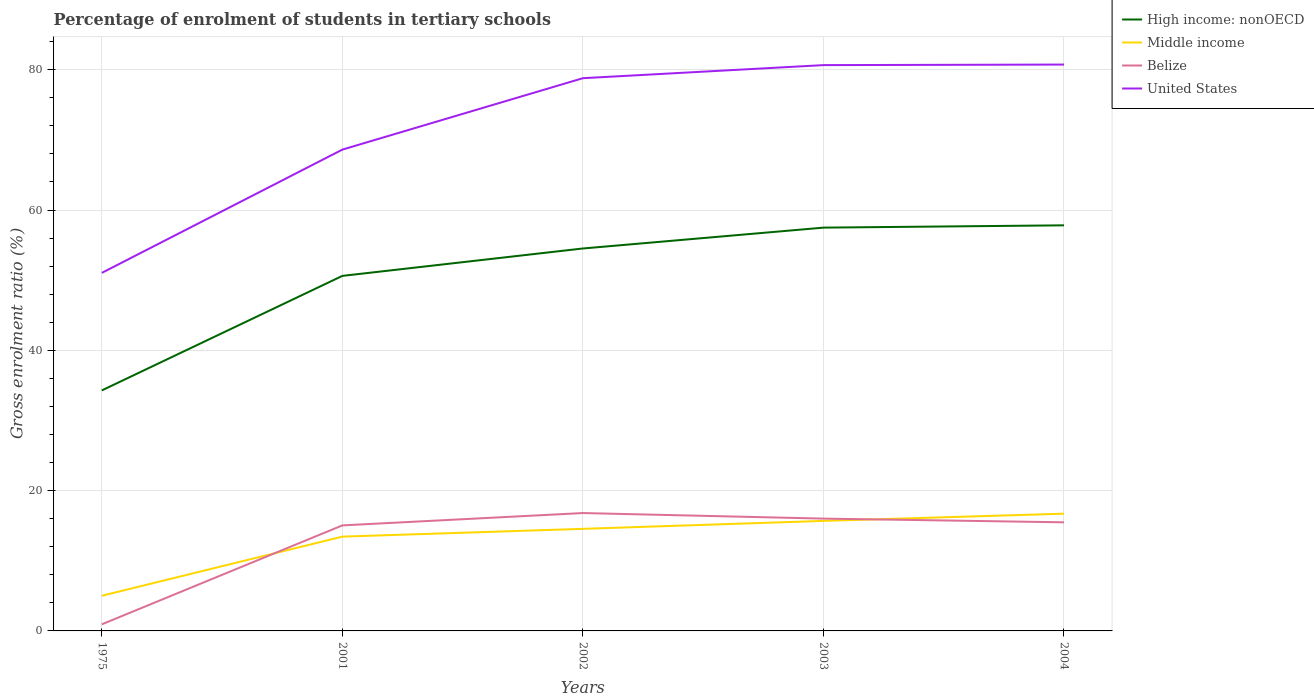Does the line corresponding to Middle income intersect with the line corresponding to High income: nonOECD?
Offer a very short reply. No. Across all years, what is the maximum percentage of students enrolled in tertiary schools in High income: nonOECD?
Give a very brief answer. 34.29. In which year was the percentage of students enrolled in tertiary schools in United States maximum?
Your answer should be very brief. 1975. What is the total percentage of students enrolled in tertiary schools in High income: nonOECD in the graph?
Provide a succinct answer. -23.53. What is the difference between the highest and the second highest percentage of students enrolled in tertiary schools in Belize?
Give a very brief answer. 15.86. How many lines are there?
Provide a succinct answer. 4. What is the difference between two consecutive major ticks on the Y-axis?
Provide a short and direct response. 20. Does the graph contain any zero values?
Provide a short and direct response. No. Does the graph contain grids?
Your response must be concise. Yes. How many legend labels are there?
Your answer should be compact. 4. How are the legend labels stacked?
Your answer should be compact. Vertical. What is the title of the graph?
Give a very brief answer. Percentage of enrolment of students in tertiary schools. Does "Bolivia" appear as one of the legend labels in the graph?
Provide a short and direct response. No. What is the label or title of the Y-axis?
Keep it short and to the point. Gross enrolment ratio (%). What is the Gross enrolment ratio (%) in High income: nonOECD in 1975?
Provide a succinct answer. 34.29. What is the Gross enrolment ratio (%) of Middle income in 1975?
Ensure brevity in your answer.  5.01. What is the Gross enrolment ratio (%) in Belize in 1975?
Offer a very short reply. 0.94. What is the Gross enrolment ratio (%) of United States in 1975?
Offer a very short reply. 51.04. What is the Gross enrolment ratio (%) in High income: nonOECD in 2001?
Offer a terse response. 50.62. What is the Gross enrolment ratio (%) of Middle income in 2001?
Your answer should be compact. 13.44. What is the Gross enrolment ratio (%) in Belize in 2001?
Give a very brief answer. 15.04. What is the Gross enrolment ratio (%) in United States in 2001?
Provide a succinct answer. 68.62. What is the Gross enrolment ratio (%) in High income: nonOECD in 2002?
Your answer should be very brief. 54.52. What is the Gross enrolment ratio (%) in Middle income in 2002?
Keep it short and to the point. 14.55. What is the Gross enrolment ratio (%) of Belize in 2002?
Ensure brevity in your answer.  16.8. What is the Gross enrolment ratio (%) of United States in 2002?
Your response must be concise. 78.8. What is the Gross enrolment ratio (%) in High income: nonOECD in 2003?
Give a very brief answer. 57.49. What is the Gross enrolment ratio (%) of Middle income in 2003?
Provide a succinct answer. 15.69. What is the Gross enrolment ratio (%) of Belize in 2003?
Keep it short and to the point. 16.01. What is the Gross enrolment ratio (%) of United States in 2003?
Offer a very short reply. 80.66. What is the Gross enrolment ratio (%) in High income: nonOECD in 2004?
Provide a short and direct response. 57.82. What is the Gross enrolment ratio (%) in Middle income in 2004?
Provide a succinct answer. 16.71. What is the Gross enrolment ratio (%) in Belize in 2004?
Provide a succinct answer. 15.48. What is the Gross enrolment ratio (%) in United States in 2004?
Offer a terse response. 80.74. Across all years, what is the maximum Gross enrolment ratio (%) of High income: nonOECD?
Your answer should be compact. 57.82. Across all years, what is the maximum Gross enrolment ratio (%) in Middle income?
Keep it short and to the point. 16.71. Across all years, what is the maximum Gross enrolment ratio (%) in Belize?
Provide a succinct answer. 16.8. Across all years, what is the maximum Gross enrolment ratio (%) in United States?
Provide a short and direct response. 80.74. Across all years, what is the minimum Gross enrolment ratio (%) of High income: nonOECD?
Ensure brevity in your answer.  34.29. Across all years, what is the minimum Gross enrolment ratio (%) of Middle income?
Give a very brief answer. 5.01. Across all years, what is the minimum Gross enrolment ratio (%) of Belize?
Provide a succinct answer. 0.94. Across all years, what is the minimum Gross enrolment ratio (%) in United States?
Offer a very short reply. 51.04. What is the total Gross enrolment ratio (%) in High income: nonOECD in the graph?
Ensure brevity in your answer.  254.74. What is the total Gross enrolment ratio (%) in Middle income in the graph?
Ensure brevity in your answer.  65.41. What is the total Gross enrolment ratio (%) of Belize in the graph?
Ensure brevity in your answer.  64.29. What is the total Gross enrolment ratio (%) in United States in the graph?
Keep it short and to the point. 359.87. What is the difference between the Gross enrolment ratio (%) in High income: nonOECD in 1975 and that in 2001?
Ensure brevity in your answer.  -16.33. What is the difference between the Gross enrolment ratio (%) of Middle income in 1975 and that in 2001?
Keep it short and to the point. -8.43. What is the difference between the Gross enrolment ratio (%) in Belize in 1975 and that in 2001?
Your answer should be compact. -14.1. What is the difference between the Gross enrolment ratio (%) of United States in 1975 and that in 2001?
Make the answer very short. -17.57. What is the difference between the Gross enrolment ratio (%) of High income: nonOECD in 1975 and that in 2002?
Keep it short and to the point. -20.23. What is the difference between the Gross enrolment ratio (%) in Middle income in 1975 and that in 2002?
Provide a short and direct response. -9.54. What is the difference between the Gross enrolment ratio (%) in Belize in 1975 and that in 2002?
Ensure brevity in your answer.  -15.86. What is the difference between the Gross enrolment ratio (%) of United States in 1975 and that in 2002?
Your answer should be compact. -27.76. What is the difference between the Gross enrolment ratio (%) in High income: nonOECD in 1975 and that in 2003?
Provide a short and direct response. -23.21. What is the difference between the Gross enrolment ratio (%) of Middle income in 1975 and that in 2003?
Keep it short and to the point. -10.67. What is the difference between the Gross enrolment ratio (%) of Belize in 1975 and that in 2003?
Provide a succinct answer. -15.07. What is the difference between the Gross enrolment ratio (%) in United States in 1975 and that in 2003?
Provide a short and direct response. -29.62. What is the difference between the Gross enrolment ratio (%) of High income: nonOECD in 1975 and that in 2004?
Your answer should be very brief. -23.53. What is the difference between the Gross enrolment ratio (%) in Middle income in 1975 and that in 2004?
Ensure brevity in your answer.  -11.7. What is the difference between the Gross enrolment ratio (%) of Belize in 1975 and that in 2004?
Your answer should be compact. -14.54. What is the difference between the Gross enrolment ratio (%) in United States in 1975 and that in 2004?
Ensure brevity in your answer.  -29.7. What is the difference between the Gross enrolment ratio (%) of High income: nonOECD in 2001 and that in 2002?
Make the answer very short. -3.91. What is the difference between the Gross enrolment ratio (%) of Middle income in 2001 and that in 2002?
Your answer should be very brief. -1.11. What is the difference between the Gross enrolment ratio (%) of Belize in 2001 and that in 2002?
Give a very brief answer. -1.76. What is the difference between the Gross enrolment ratio (%) in United States in 2001 and that in 2002?
Ensure brevity in your answer.  -10.18. What is the difference between the Gross enrolment ratio (%) in High income: nonOECD in 2001 and that in 2003?
Give a very brief answer. -6.88. What is the difference between the Gross enrolment ratio (%) of Middle income in 2001 and that in 2003?
Offer a very short reply. -2.24. What is the difference between the Gross enrolment ratio (%) of Belize in 2001 and that in 2003?
Provide a short and direct response. -0.97. What is the difference between the Gross enrolment ratio (%) of United States in 2001 and that in 2003?
Provide a succinct answer. -12.04. What is the difference between the Gross enrolment ratio (%) in High income: nonOECD in 2001 and that in 2004?
Ensure brevity in your answer.  -7.21. What is the difference between the Gross enrolment ratio (%) in Middle income in 2001 and that in 2004?
Your response must be concise. -3.27. What is the difference between the Gross enrolment ratio (%) of Belize in 2001 and that in 2004?
Give a very brief answer. -0.44. What is the difference between the Gross enrolment ratio (%) of United States in 2001 and that in 2004?
Keep it short and to the point. -12.12. What is the difference between the Gross enrolment ratio (%) in High income: nonOECD in 2002 and that in 2003?
Your answer should be compact. -2.97. What is the difference between the Gross enrolment ratio (%) of Middle income in 2002 and that in 2003?
Provide a short and direct response. -1.13. What is the difference between the Gross enrolment ratio (%) in Belize in 2002 and that in 2003?
Your answer should be compact. 0.79. What is the difference between the Gross enrolment ratio (%) in United States in 2002 and that in 2003?
Make the answer very short. -1.86. What is the difference between the Gross enrolment ratio (%) in High income: nonOECD in 2002 and that in 2004?
Ensure brevity in your answer.  -3.3. What is the difference between the Gross enrolment ratio (%) in Middle income in 2002 and that in 2004?
Ensure brevity in your answer.  -2.16. What is the difference between the Gross enrolment ratio (%) of Belize in 2002 and that in 2004?
Make the answer very short. 1.32. What is the difference between the Gross enrolment ratio (%) in United States in 2002 and that in 2004?
Offer a terse response. -1.94. What is the difference between the Gross enrolment ratio (%) of High income: nonOECD in 2003 and that in 2004?
Offer a terse response. -0.33. What is the difference between the Gross enrolment ratio (%) of Middle income in 2003 and that in 2004?
Your response must be concise. -1.03. What is the difference between the Gross enrolment ratio (%) of Belize in 2003 and that in 2004?
Give a very brief answer. 0.53. What is the difference between the Gross enrolment ratio (%) of United States in 2003 and that in 2004?
Provide a succinct answer. -0.08. What is the difference between the Gross enrolment ratio (%) in High income: nonOECD in 1975 and the Gross enrolment ratio (%) in Middle income in 2001?
Offer a terse response. 20.85. What is the difference between the Gross enrolment ratio (%) in High income: nonOECD in 1975 and the Gross enrolment ratio (%) in Belize in 2001?
Your response must be concise. 19.24. What is the difference between the Gross enrolment ratio (%) in High income: nonOECD in 1975 and the Gross enrolment ratio (%) in United States in 2001?
Your response must be concise. -34.33. What is the difference between the Gross enrolment ratio (%) in Middle income in 1975 and the Gross enrolment ratio (%) in Belize in 2001?
Offer a very short reply. -10.03. What is the difference between the Gross enrolment ratio (%) in Middle income in 1975 and the Gross enrolment ratio (%) in United States in 2001?
Provide a short and direct response. -63.6. What is the difference between the Gross enrolment ratio (%) of Belize in 1975 and the Gross enrolment ratio (%) of United States in 2001?
Your answer should be very brief. -67.68. What is the difference between the Gross enrolment ratio (%) of High income: nonOECD in 1975 and the Gross enrolment ratio (%) of Middle income in 2002?
Your answer should be very brief. 19.74. What is the difference between the Gross enrolment ratio (%) in High income: nonOECD in 1975 and the Gross enrolment ratio (%) in Belize in 2002?
Provide a succinct answer. 17.48. What is the difference between the Gross enrolment ratio (%) of High income: nonOECD in 1975 and the Gross enrolment ratio (%) of United States in 2002?
Offer a very short reply. -44.51. What is the difference between the Gross enrolment ratio (%) of Middle income in 1975 and the Gross enrolment ratio (%) of Belize in 2002?
Your answer should be very brief. -11.79. What is the difference between the Gross enrolment ratio (%) of Middle income in 1975 and the Gross enrolment ratio (%) of United States in 2002?
Ensure brevity in your answer.  -73.79. What is the difference between the Gross enrolment ratio (%) of Belize in 1975 and the Gross enrolment ratio (%) of United States in 2002?
Offer a very short reply. -77.86. What is the difference between the Gross enrolment ratio (%) in High income: nonOECD in 1975 and the Gross enrolment ratio (%) in Middle income in 2003?
Ensure brevity in your answer.  18.6. What is the difference between the Gross enrolment ratio (%) of High income: nonOECD in 1975 and the Gross enrolment ratio (%) of Belize in 2003?
Make the answer very short. 18.28. What is the difference between the Gross enrolment ratio (%) in High income: nonOECD in 1975 and the Gross enrolment ratio (%) in United States in 2003?
Offer a very short reply. -46.37. What is the difference between the Gross enrolment ratio (%) in Middle income in 1975 and the Gross enrolment ratio (%) in Belize in 2003?
Your answer should be compact. -11. What is the difference between the Gross enrolment ratio (%) in Middle income in 1975 and the Gross enrolment ratio (%) in United States in 2003?
Keep it short and to the point. -75.65. What is the difference between the Gross enrolment ratio (%) of Belize in 1975 and the Gross enrolment ratio (%) of United States in 2003?
Your answer should be compact. -79.72. What is the difference between the Gross enrolment ratio (%) of High income: nonOECD in 1975 and the Gross enrolment ratio (%) of Middle income in 2004?
Offer a very short reply. 17.58. What is the difference between the Gross enrolment ratio (%) in High income: nonOECD in 1975 and the Gross enrolment ratio (%) in Belize in 2004?
Ensure brevity in your answer.  18.81. What is the difference between the Gross enrolment ratio (%) in High income: nonOECD in 1975 and the Gross enrolment ratio (%) in United States in 2004?
Provide a short and direct response. -46.45. What is the difference between the Gross enrolment ratio (%) in Middle income in 1975 and the Gross enrolment ratio (%) in Belize in 2004?
Offer a terse response. -10.47. What is the difference between the Gross enrolment ratio (%) of Middle income in 1975 and the Gross enrolment ratio (%) of United States in 2004?
Give a very brief answer. -75.73. What is the difference between the Gross enrolment ratio (%) of Belize in 1975 and the Gross enrolment ratio (%) of United States in 2004?
Ensure brevity in your answer.  -79.8. What is the difference between the Gross enrolment ratio (%) of High income: nonOECD in 2001 and the Gross enrolment ratio (%) of Middle income in 2002?
Offer a very short reply. 36.06. What is the difference between the Gross enrolment ratio (%) of High income: nonOECD in 2001 and the Gross enrolment ratio (%) of Belize in 2002?
Offer a terse response. 33.81. What is the difference between the Gross enrolment ratio (%) in High income: nonOECD in 2001 and the Gross enrolment ratio (%) in United States in 2002?
Give a very brief answer. -28.18. What is the difference between the Gross enrolment ratio (%) in Middle income in 2001 and the Gross enrolment ratio (%) in Belize in 2002?
Offer a very short reply. -3.36. What is the difference between the Gross enrolment ratio (%) in Middle income in 2001 and the Gross enrolment ratio (%) in United States in 2002?
Keep it short and to the point. -65.36. What is the difference between the Gross enrolment ratio (%) in Belize in 2001 and the Gross enrolment ratio (%) in United States in 2002?
Your answer should be compact. -63.75. What is the difference between the Gross enrolment ratio (%) in High income: nonOECD in 2001 and the Gross enrolment ratio (%) in Middle income in 2003?
Provide a short and direct response. 34.93. What is the difference between the Gross enrolment ratio (%) in High income: nonOECD in 2001 and the Gross enrolment ratio (%) in Belize in 2003?
Provide a succinct answer. 34.6. What is the difference between the Gross enrolment ratio (%) of High income: nonOECD in 2001 and the Gross enrolment ratio (%) of United States in 2003?
Your response must be concise. -30.05. What is the difference between the Gross enrolment ratio (%) of Middle income in 2001 and the Gross enrolment ratio (%) of Belize in 2003?
Your response must be concise. -2.57. What is the difference between the Gross enrolment ratio (%) in Middle income in 2001 and the Gross enrolment ratio (%) in United States in 2003?
Give a very brief answer. -67.22. What is the difference between the Gross enrolment ratio (%) in Belize in 2001 and the Gross enrolment ratio (%) in United States in 2003?
Make the answer very short. -65.62. What is the difference between the Gross enrolment ratio (%) of High income: nonOECD in 2001 and the Gross enrolment ratio (%) of Middle income in 2004?
Provide a short and direct response. 33.9. What is the difference between the Gross enrolment ratio (%) in High income: nonOECD in 2001 and the Gross enrolment ratio (%) in Belize in 2004?
Provide a short and direct response. 35.13. What is the difference between the Gross enrolment ratio (%) in High income: nonOECD in 2001 and the Gross enrolment ratio (%) in United States in 2004?
Your answer should be compact. -30.13. What is the difference between the Gross enrolment ratio (%) of Middle income in 2001 and the Gross enrolment ratio (%) of Belize in 2004?
Offer a terse response. -2.04. What is the difference between the Gross enrolment ratio (%) of Middle income in 2001 and the Gross enrolment ratio (%) of United States in 2004?
Keep it short and to the point. -67.3. What is the difference between the Gross enrolment ratio (%) in Belize in 2001 and the Gross enrolment ratio (%) in United States in 2004?
Your response must be concise. -65.7. What is the difference between the Gross enrolment ratio (%) of High income: nonOECD in 2002 and the Gross enrolment ratio (%) of Middle income in 2003?
Make the answer very short. 38.84. What is the difference between the Gross enrolment ratio (%) of High income: nonOECD in 2002 and the Gross enrolment ratio (%) of Belize in 2003?
Keep it short and to the point. 38.51. What is the difference between the Gross enrolment ratio (%) of High income: nonOECD in 2002 and the Gross enrolment ratio (%) of United States in 2003?
Your answer should be compact. -26.14. What is the difference between the Gross enrolment ratio (%) of Middle income in 2002 and the Gross enrolment ratio (%) of Belize in 2003?
Provide a short and direct response. -1.46. What is the difference between the Gross enrolment ratio (%) of Middle income in 2002 and the Gross enrolment ratio (%) of United States in 2003?
Keep it short and to the point. -66.11. What is the difference between the Gross enrolment ratio (%) in Belize in 2002 and the Gross enrolment ratio (%) in United States in 2003?
Provide a short and direct response. -63.86. What is the difference between the Gross enrolment ratio (%) in High income: nonOECD in 2002 and the Gross enrolment ratio (%) in Middle income in 2004?
Ensure brevity in your answer.  37.81. What is the difference between the Gross enrolment ratio (%) of High income: nonOECD in 2002 and the Gross enrolment ratio (%) of Belize in 2004?
Offer a terse response. 39.04. What is the difference between the Gross enrolment ratio (%) in High income: nonOECD in 2002 and the Gross enrolment ratio (%) in United States in 2004?
Your answer should be compact. -26.22. What is the difference between the Gross enrolment ratio (%) of Middle income in 2002 and the Gross enrolment ratio (%) of Belize in 2004?
Keep it short and to the point. -0.93. What is the difference between the Gross enrolment ratio (%) of Middle income in 2002 and the Gross enrolment ratio (%) of United States in 2004?
Your response must be concise. -66.19. What is the difference between the Gross enrolment ratio (%) in Belize in 2002 and the Gross enrolment ratio (%) in United States in 2004?
Keep it short and to the point. -63.94. What is the difference between the Gross enrolment ratio (%) in High income: nonOECD in 2003 and the Gross enrolment ratio (%) in Middle income in 2004?
Your answer should be very brief. 40.78. What is the difference between the Gross enrolment ratio (%) of High income: nonOECD in 2003 and the Gross enrolment ratio (%) of Belize in 2004?
Your response must be concise. 42.01. What is the difference between the Gross enrolment ratio (%) in High income: nonOECD in 2003 and the Gross enrolment ratio (%) in United States in 2004?
Your answer should be compact. -23.25. What is the difference between the Gross enrolment ratio (%) in Middle income in 2003 and the Gross enrolment ratio (%) in Belize in 2004?
Give a very brief answer. 0.2. What is the difference between the Gross enrolment ratio (%) of Middle income in 2003 and the Gross enrolment ratio (%) of United States in 2004?
Your answer should be very brief. -65.06. What is the difference between the Gross enrolment ratio (%) in Belize in 2003 and the Gross enrolment ratio (%) in United States in 2004?
Ensure brevity in your answer.  -64.73. What is the average Gross enrolment ratio (%) in High income: nonOECD per year?
Give a very brief answer. 50.95. What is the average Gross enrolment ratio (%) in Middle income per year?
Provide a short and direct response. 13.08. What is the average Gross enrolment ratio (%) of Belize per year?
Your response must be concise. 12.86. What is the average Gross enrolment ratio (%) in United States per year?
Provide a succinct answer. 71.97. In the year 1975, what is the difference between the Gross enrolment ratio (%) of High income: nonOECD and Gross enrolment ratio (%) of Middle income?
Offer a very short reply. 29.28. In the year 1975, what is the difference between the Gross enrolment ratio (%) of High income: nonOECD and Gross enrolment ratio (%) of Belize?
Provide a succinct answer. 33.35. In the year 1975, what is the difference between the Gross enrolment ratio (%) of High income: nonOECD and Gross enrolment ratio (%) of United States?
Make the answer very short. -16.76. In the year 1975, what is the difference between the Gross enrolment ratio (%) of Middle income and Gross enrolment ratio (%) of Belize?
Give a very brief answer. 4.07. In the year 1975, what is the difference between the Gross enrolment ratio (%) in Middle income and Gross enrolment ratio (%) in United States?
Your answer should be very brief. -46.03. In the year 1975, what is the difference between the Gross enrolment ratio (%) of Belize and Gross enrolment ratio (%) of United States?
Your response must be concise. -50.1. In the year 2001, what is the difference between the Gross enrolment ratio (%) in High income: nonOECD and Gross enrolment ratio (%) in Middle income?
Give a very brief answer. 37.17. In the year 2001, what is the difference between the Gross enrolment ratio (%) of High income: nonOECD and Gross enrolment ratio (%) of Belize?
Provide a succinct answer. 35.57. In the year 2001, what is the difference between the Gross enrolment ratio (%) in High income: nonOECD and Gross enrolment ratio (%) in United States?
Keep it short and to the point. -18. In the year 2001, what is the difference between the Gross enrolment ratio (%) of Middle income and Gross enrolment ratio (%) of Belize?
Make the answer very short. -1.6. In the year 2001, what is the difference between the Gross enrolment ratio (%) in Middle income and Gross enrolment ratio (%) in United States?
Your answer should be very brief. -55.18. In the year 2001, what is the difference between the Gross enrolment ratio (%) of Belize and Gross enrolment ratio (%) of United States?
Provide a succinct answer. -53.57. In the year 2002, what is the difference between the Gross enrolment ratio (%) of High income: nonOECD and Gross enrolment ratio (%) of Middle income?
Provide a succinct answer. 39.97. In the year 2002, what is the difference between the Gross enrolment ratio (%) in High income: nonOECD and Gross enrolment ratio (%) in Belize?
Offer a terse response. 37.72. In the year 2002, what is the difference between the Gross enrolment ratio (%) in High income: nonOECD and Gross enrolment ratio (%) in United States?
Your answer should be very brief. -24.28. In the year 2002, what is the difference between the Gross enrolment ratio (%) in Middle income and Gross enrolment ratio (%) in Belize?
Your response must be concise. -2.25. In the year 2002, what is the difference between the Gross enrolment ratio (%) in Middle income and Gross enrolment ratio (%) in United States?
Keep it short and to the point. -64.25. In the year 2002, what is the difference between the Gross enrolment ratio (%) of Belize and Gross enrolment ratio (%) of United States?
Provide a succinct answer. -62. In the year 2003, what is the difference between the Gross enrolment ratio (%) in High income: nonOECD and Gross enrolment ratio (%) in Middle income?
Your response must be concise. 41.81. In the year 2003, what is the difference between the Gross enrolment ratio (%) in High income: nonOECD and Gross enrolment ratio (%) in Belize?
Provide a short and direct response. 41.48. In the year 2003, what is the difference between the Gross enrolment ratio (%) in High income: nonOECD and Gross enrolment ratio (%) in United States?
Make the answer very short. -23.17. In the year 2003, what is the difference between the Gross enrolment ratio (%) of Middle income and Gross enrolment ratio (%) of Belize?
Keep it short and to the point. -0.33. In the year 2003, what is the difference between the Gross enrolment ratio (%) of Middle income and Gross enrolment ratio (%) of United States?
Your answer should be compact. -64.98. In the year 2003, what is the difference between the Gross enrolment ratio (%) of Belize and Gross enrolment ratio (%) of United States?
Give a very brief answer. -64.65. In the year 2004, what is the difference between the Gross enrolment ratio (%) in High income: nonOECD and Gross enrolment ratio (%) in Middle income?
Your answer should be very brief. 41.11. In the year 2004, what is the difference between the Gross enrolment ratio (%) in High income: nonOECD and Gross enrolment ratio (%) in Belize?
Your answer should be very brief. 42.34. In the year 2004, what is the difference between the Gross enrolment ratio (%) in High income: nonOECD and Gross enrolment ratio (%) in United States?
Offer a terse response. -22.92. In the year 2004, what is the difference between the Gross enrolment ratio (%) of Middle income and Gross enrolment ratio (%) of Belize?
Your answer should be very brief. 1.23. In the year 2004, what is the difference between the Gross enrolment ratio (%) of Middle income and Gross enrolment ratio (%) of United States?
Give a very brief answer. -64.03. In the year 2004, what is the difference between the Gross enrolment ratio (%) in Belize and Gross enrolment ratio (%) in United States?
Your response must be concise. -65.26. What is the ratio of the Gross enrolment ratio (%) in High income: nonOECD in 1975 to that in 2001?
Give a very brief answer. 0.68. What is the ratio of the Gross enrolment ratio (%) in Middle income in 1975 to that in 2001?
Offer a very short reply. 0.37. What is the ratio of the Gross enrolment ratio (%) in Belize in 1975 to that in 2001?
Provide a short and direct response. 0.06. What is the ratio of the Gross enrolment ratio (%) in United States in 1975 to that in 2001?
Keep it short and to the point. 0.74. What is the ratio of the Gross enrolment ratio (%) in High income: nonOECD in 1975 to that in 2002?
Provide a succinct answer. 0.63. What is the ratio of the Gross enrolment ratio (%) in Middle income in 1975 to that in 2002?
Give a very brief answer. 0.34. What is the ratio of the Gross enrolment ratio (%) in Belize in 1975 to that in 2002?
Provide a succinct answer. 0.06. What is the ratio of the Gross enrolment ratio (%) of United States in 1975 to that in 2002?
Your response must be concise. 0.65. What is the ratio of the Gross enrolment ratio (%) in High income: nonOECD in 1975 to that in 2003?
Your answer should be very brief. 0.6. What is the ratio of the Gross enrolment ratio (%) of Middle income in 1975 to that in 2003?
Your answer should be compact. 0.32. What is the ratio of the Gross enrolment ratio (%) in Belize in 1975 to that in 2003?
Offer a terse response. 0.06. What is the ratio of the Gross enrolment ratio (%) of United States in 1975 to that in 2003?
Offer a terse response. 0.63. What is the ratio of the Gross enrolment ratio (%) of High income: nonOECD in 1975 to that in 2004?
Your answer should be very brief. 0.59. What is the ratio of the Gross enrolment ratio (%) in Belize in 1975 to that in 2004?
Your answer should be very brief. 0.06. What is the ratio of the Gross enrolment ratio (%) of United States in 1975 to that in 2004?
Your answer should be very brief. 0.63. What is the ratio of the Gross enrolment ratio (%) in High income: nonOECD in 2001 to that in 2002?
Make the answer very short. 0.93. What is the ratio of the Gross enrolment ratio (%) in Middle income in 2001 to that in 2002?
Provide a short and direct response. 0.92. What is the ratio of the Gross enrolment ratio (%) in Belize in 2001 to that in 2002?
Offer a very short reply. 0.9. What is the ratio of the Gross enrolment ratio (%) of United States in 2001 to that in 2002?
Ensure brevity in your answer.  0.87. What is the ratio of the Gross enrolment ratio (%) in High income: nonOECD in 2001 to that in 2003?
Provide a succinct answer. 0.88. What is the ratio of the Gross enrolment ratio (%) of Middle income in 2001 to that in 2003?
Make the answer very short. 0.86. What is the ratio of the Gross enrolment ratio (%) in Belize in 2001 to that in 2003?
Make the answer very short. 0.94. What is the ratio of the Gross enrolment ratio (%) in United States in 2001 to that in 2003?
Offer a very short reply. 0.85. What is the ratio of the Gross enrolment ratio (%) in High income: nonOECD in 2001 to that in 2004?
Provide a succinct answer. 0.88. What is the ratio of the Gross enrolment ratio (%) in Middle income in 2001 to that in 2004?
Offer a terse response. 0.8. What is the ratio of the Gross enrolment ratio (%) in Belize in 2001 to that in 2004?
Provide a succinct answer. 0.97. What is the ratio of the Gross enrolment ratio (%) in United States in 2001 to that in 2004?
Ensure brevity in your answer.  0.85. What is the ratio of the Gross enrolment ratio (%) of High income: nonOECD in 2002 to that in 2003?
Provide a succinct answer. 0.95. What is the ratio of the Gross enrolment ratio (%) of Middle income in 2002 to that in 2003?
Provide a short and direct response. 0.93. What is the ratio of the Gross enrolment ratio (%) of Belize in 2002 to that in 2003?
Ensure brevity in your answer.  1.05. What is the ratio of the Gross enrolment ratio (%) of United States in 2002 to that in 2003?
Keep it short and to the point. 0.98. What is the ratio of the Gross enrolment ratio (%) of High income: nonOECD in 2002 to that in 2004?
Your answer should be very brief. 0.94. What is the ratio of the Gross enrolment ratio (%) in Middle income in 2002 to that in 2004?
Make the answer very short. 0.87. What is the ratio of the Gross enrolment ratio (%) in Belize in 2002 to that in 2004?
Your answer should be very brief. 1.09. What is the ratio of the Gross enrolment ratio (%) in United States in 2002 to that in 2004?
Keep it short and to the point. 0.98. What is the ratio of the Gross enrolment ratio (%) of High income: nonOECD in 2003 to that in 2004?
Give a very brief answer. 0.99. What is the ratio of the Gross enrolment ratio (%) of Middle income in 2003 to that in 2004?
Offer a very short reply. 0.94. What is the ratio of the Gross enrolment ratio (%) of Belize in 2003 to that in 2004?
Offer a terse response. 1.03. What is the ratio of the Gross enrolment ratio (%) of United States in 2003 to that in 2004?
Provide a short and direct response. 1. What is the difference between the highest and the second highest Gross enrolment ratio (%) in High income: nonOECD?
Provide a succinct answer. 0.33. What is the difference between the highest and the second highest Gross enrolment ratio (%) of Middle income?
Your answer should be very brief. 1.03. What is the difference between the highest and the second highest Gross enrolment ratio (%) of Belize?
Provide a succinct answer. 0.79. What is the difference between the highest and the second highest Gross enrolment ratio (%) of United States?
Make the answer very short. 0.08. What is the difference between the highest and the lowest Gross enrolment ratio (%) in High income: nonOECD?
Offer a very short reply. 23.53. What is the difference between the highest and the lowest Gross enrolment ratio (%) of Middle income?
Ensure brevity in your answer.  11.7. What is the difference between the highest and the lowest Gross enrolment ratio (%) in Belize?
Provide a succinct answer. 15.86. What is the difference between the highest and the lowest Gross enrolment ratio (%) in United States?
Offer a terse response. 29.7. 